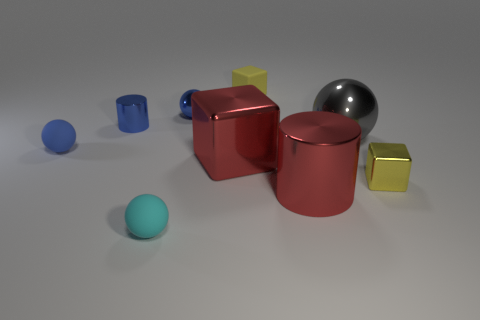How many blue spheres must be subtracted to get 1 blue spheres? 1 Subtract all small blue metallic balls. How many balls are left? 3 Subtract all yellow blocks. How many blue spheres are left? 2 Add 1 cyan balls. How many objects exist? 10 Subtract all red cylinders. How many cylinders are left? 1 Subtract 2 spheres. How many spheres are left? 2 Subtract all blue cylinders. Subtract all tiny metallic blocks. How many objects are left? 7 Add 6 tiny cyan balls. How many tiny cyan balls are left? 7 Add 7 small blue metal things. How many small blue metal things exist? 9 Subtract 1 blue cylinders. How many objects are left? 8 